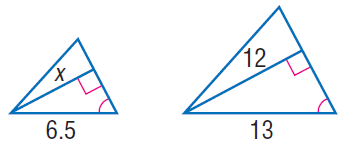Question: Find x.
Choices:
A. 6
B. 12
C. 18
D. 24
Answer with the letter. Answer: A 